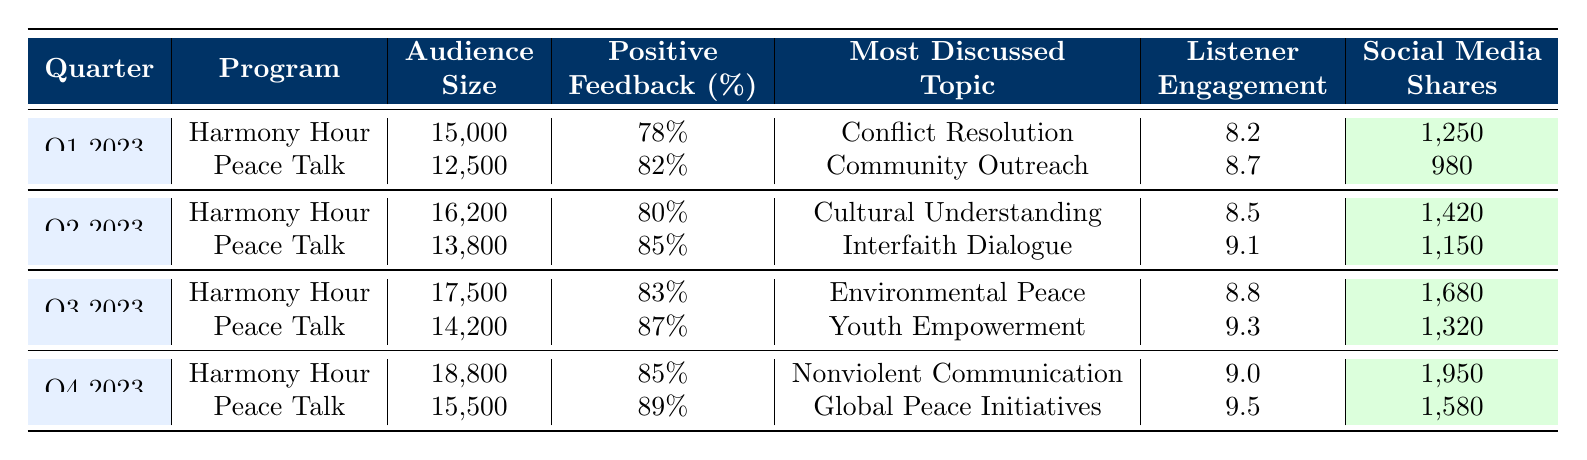What was the audience size for "Peace Talk" in Q4 2023? The table shows that the audience size for "Peace Talk" in Q4 2023 is listed as 15,500.
Answer: 15,500 Which program had the highest positive feedback percentage in Q3 2023? In Q3 2023, "Peace Talk" had a positive feedback percentage of 87%, whereas "Harmony Hour" had 83%. Therefore, "Peace Talk" had the highest percentage.
Answer: Peace Talk What is the total audience size for both programs in Q2 2023? The audience size for "Harmony Hour" in Q2 2023 is 16,200, and for "Peace Talk," it is 13,800. Adding these together gives 16,200 + 13,800 = 30,000.
Answer: 30,000 Did "Harmony Hour" ever have a higher listener engagement score than "Peace Talk"? In Q4 2023, "Harmony Hour" had a listener engagement score of 9.0, while "Peace Talk" had a score of 9.5. Thus, "Harmony Hour" did not have a higher score in that quarter. In the other quarters similarly, "Peace Talk" had higher scores as well.
Answer: No What is the average positive feedback percentage for "Harmony Hour" across all quarters? The positive feedback percentages for "Harmony Hour" are 78%, 80%, 83%, and 85%. Adding these up gives 78 + 80 + 83 + 85 = 326. There are 4 data points, therefore the average is 326/4 = 81.5.
Answer: 81.5 Which quarter had the most social media shares for "Harmony Hour"? The table lists social media shares for "Harmony Hour" as 1,250 in Q1, 1,420 in Q2, 1,680 in Q3, and 1,950 in Q4. The highest number is in Q4 with 1,950 shares.
Answer: Q4 2023 What is the difference in listener engagement scores between the two programs in Q1 2023? The listener engagement score for "Harmony Hour" is 8.2 and for "Peace Talk" is 8.7. The difference is 8.7 - 8.2 = 0.5.
Answer: 0.5 In which quarter did "Peace Talk" have the most discussion about "Youth Empowerment"? "Peace Talk" discussed "Youth Empowerment" in Q3 2023 only. Hence, that's the only quarter that had this topic.
Answer: Q3 2023 Which program had a consistently increasing audience size from Q1 to Q4 2023? Checking the audience sizes, "Harmony Hour" increased from 15,000 in Q1 to 18,800 in Q4, showing a consistent increase. "Peace Talk" also increased but not consistently in every quarter.
Answer: Harmony Hour What percentage of positive feedback did "Peace Talk" receive in Q2 2023? The table indicates that "Peace Talk" received 85% positive feedback in Q2 2023.
Answer: 85% What was the most discussed topic on "Harmony Hour" over the four quarters? Analyzing the table, the most discussed topics for "Harmony Hour" were: Q1 - Conflict Resolution, Q2 - Cultural Understanding, Q3 - Environmental Peace, and Q4 - Nonviolent Communication. The topics varied each quarter, so there isn't one singular topic across all quarters.
Answer: Varied topics each quarter 